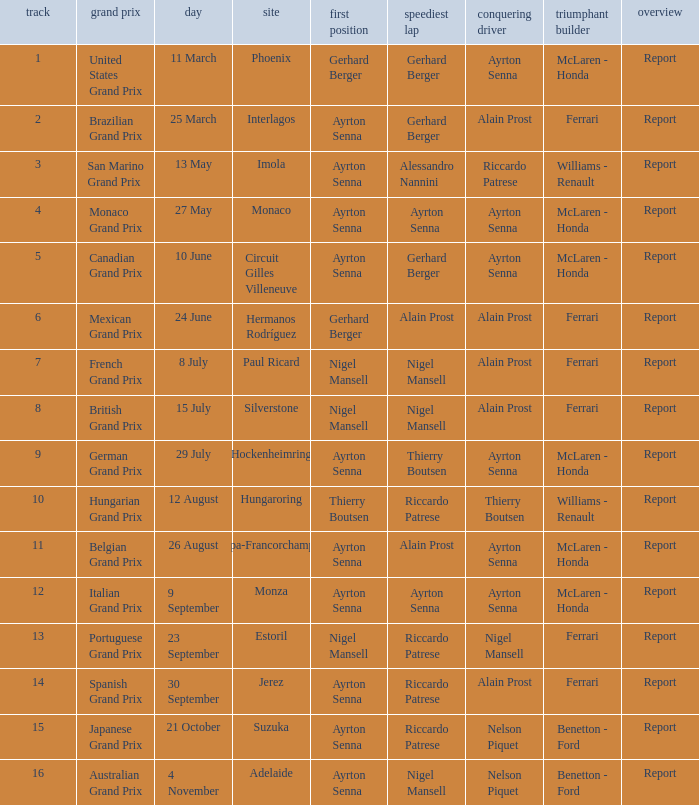What was the constructor when riccardo patrese was the winning driver? Williams - Renault. 